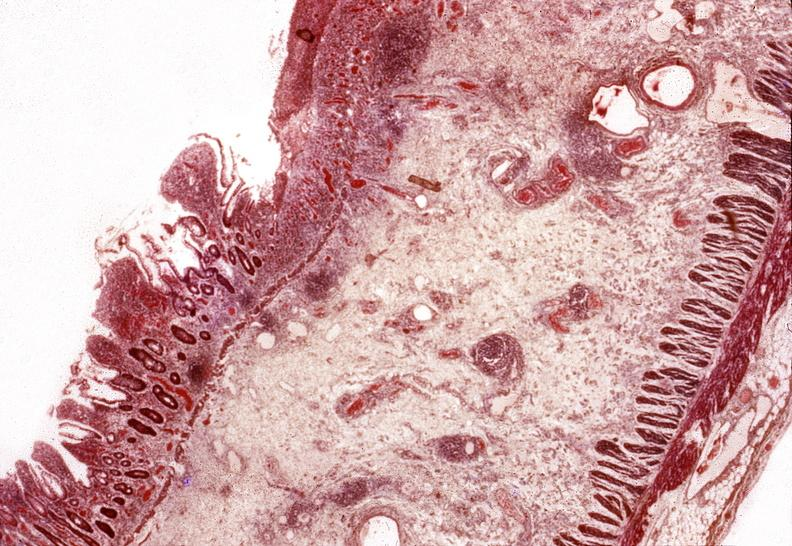what does this image show?
Answer the question using a single word or phrase. Small intestine 